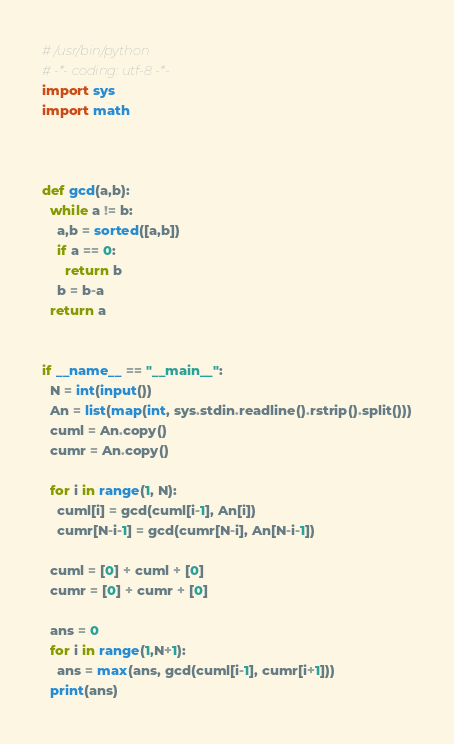<code> <loc_0><loc_0><loc_500><loc_500><_Python_># /usr/bin/python
# -*- coding: utf-8 -*-
import sys
import math



def gcd(a,b):
  while a != b:
    a,b = sorted([a,b])
    if a == 0:
      return b
    b = b-a
  return a


if __name__ == "__main__": 
  N = int(input())
  An = list(map(int, sys.stdin.readline().rstrip().split()))
  cuml = An.copy()
  cumr = An.copy()

  for i in range(1, N):
    cuml[i] = gcd(cuml[i-1], An[i])
    cumr[N-i-1] = gcd(cumr[N-i], An[N-i-1])

  cuml = [0] + cuml + [0]
  cumr = [0] + cumr + [0]

  ans = 0
  for i in range(1,N+1):
    ans = max(ans, gcd(cuml[i-1], cumr[i+1]))
  print(ans)</code> 